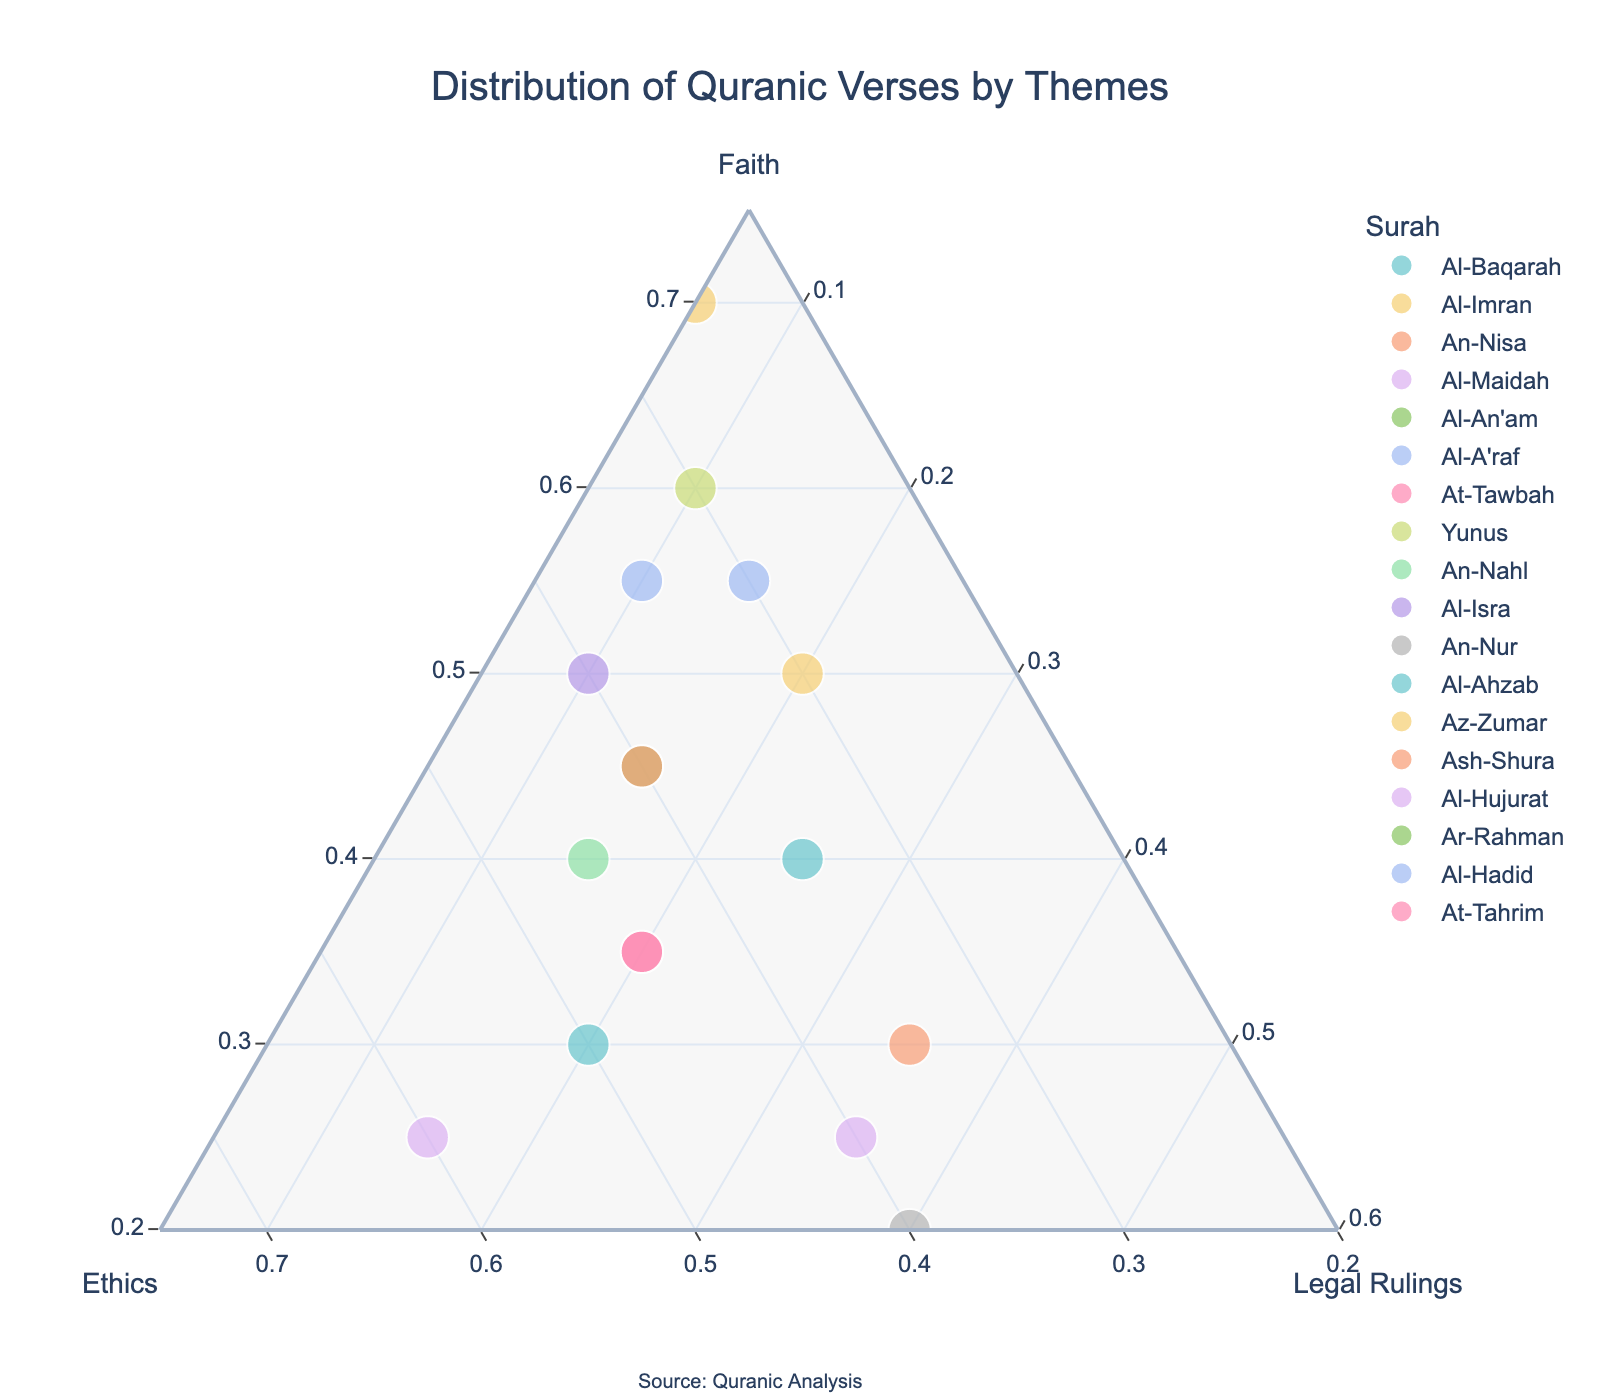1. What surah has the highest proportion of verses dedicated to faith? By observing the plot, the surah at the top of the ternary plot represents the highest proportion of faith. This is Ar-Rahman with faith at 80.
Answer: Ar-Rahman 2. Which surah has an equal distribution between ethics and legal rulings? Looking closely at the plot, the surah where the ethics and legal rulings proportions are equal is An-Nur, with both at 40.
Answer: An-Nur 3. What is the title of the plot? The title is displayed at the top of the plot. It reads "Distribution of Quranic Verses by Themes".
Answer: Distribution of Quranic Verses by Themes 4. Which surah has the lowest proportion of legal rulings? The surah positioned nearest to the "Legal Rulings" axis (wherever this axis hits the plot surface at a low value) has the lowest proportion. This is Az-Zumar with legal rulings at 5.
Answer: Az-Zumar 5. How many surahs have faith as the dominant theme compared to ethics and legal rulings? By looking at each data point's position in the ternary plot, we count the surahs where faith proportion is the highest. These are Al-Imran, Al-An'am, Al-A'raf, Yunus, Al-Isra, Az-Zumar, Ar-Rahman, and Al-Hadid.
Answer: 8 6. What is the combined proportion of ethics and legal rulings in Al-Ahzab? Al-Ahzab has ethics at 50 and legal rulings at 20, so their combined proportion is 50 + 20.
Answer: 70 7. Which surah has ethics as its dominant theme? The surah positioned furthest towards the corner representing Ethics is Al-Hujurat with ethics at 60.
Answer: Al-Hujurat 8. How does the proportion of faith in Surah Al-Maidah compare to that in Surah Al-Baqarah? Surah Al-Maidah has faith at 25, while Surah Al-Baqarah has faith at 40. Therefore, Al-Baqarah has a higher proportion of faith than Al-Maidah.
Answer: Al-Baqarah has more faith 9. Which surah has the most balanced distribution across all three themes? The most balanced surah would be closest to the center of the ternary plot. An-Nisa seems to have the most balanced proportions with 30 faith, 35 ethics, and 35 legal rulings.
Answer: An-Nisa 10. What is the sum of the faith proportions for Al-Baqarah and At-Tawbah? Adding the faith proportions for Al-Baqarah (40) and At-Tawbah (35) gives us 40 + 35.
Answer: 75 